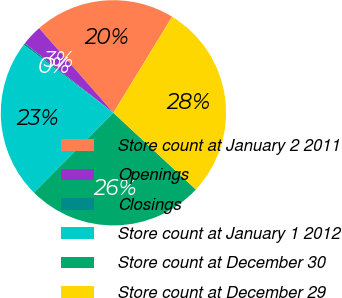<chart> <loc_0><loc_0><loc_500><loc_500><pie_chart><fcel>Store count at January 2 2011<fcel>Openings<fcel>Closings<fcel>Store count at January 1 2012<fcel>Store count at December 30<fcel>Store count at December 29<nl><fcel>20.2%<fcel>2.94%<fcel>0.27%<fcel>22.86%<fcel>25.53%<fcel>28.2%<nl></chart> 